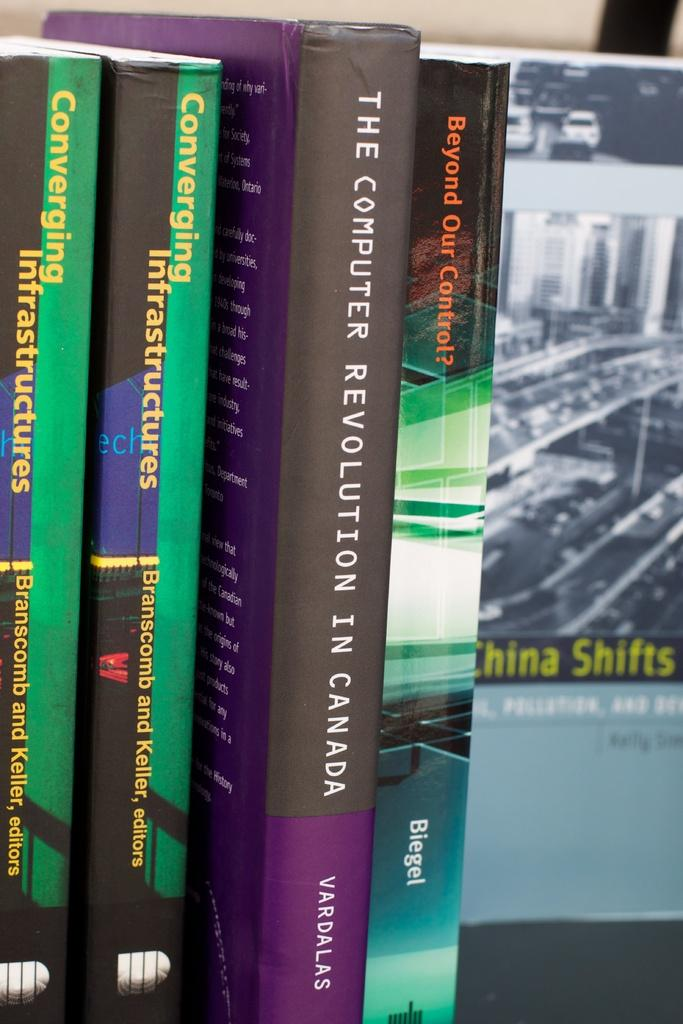<image>
Render a clear and concise summary of the photo. several books sitting next to each other like "The computer revolution in canada" by Vardalas. 